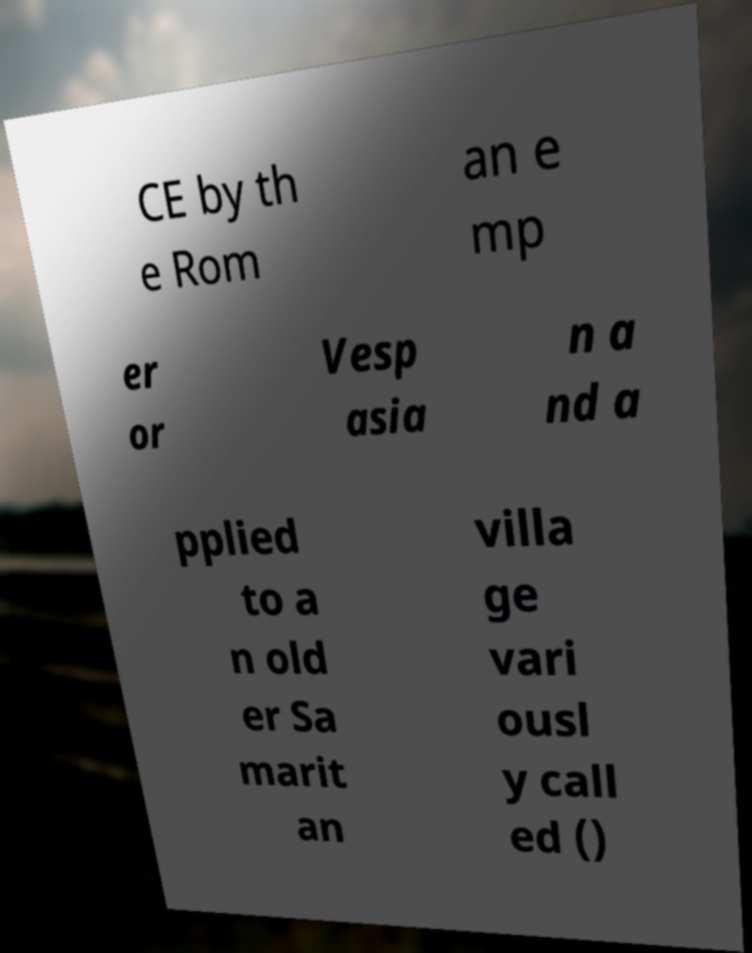For documentation purposes, I need the text within this image transcribed. Could you provide that? CE by th e Rom an e mp er or Vesp asia n a nd a pplied to a n old er Sa marit an villa ge vari ousl y call ed () 